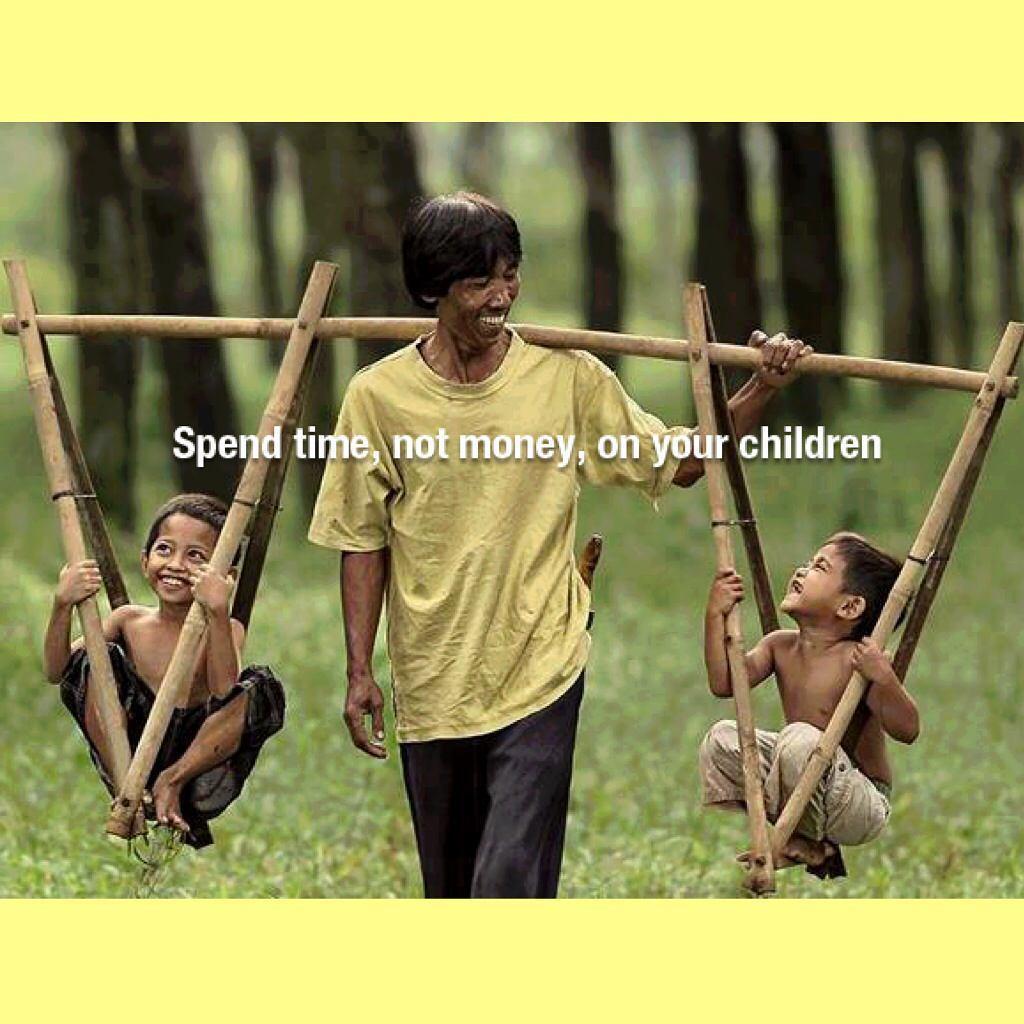Please provide a concise description of this image. In the middle of the image there is a man with green t-shirt is standing and he is laughing. And he is carrying the sticks, on the sticks there are two boys sitting. Behind the man in the background there's grass on the ground and also there are trees. And in the middle of the image there is a caption. 